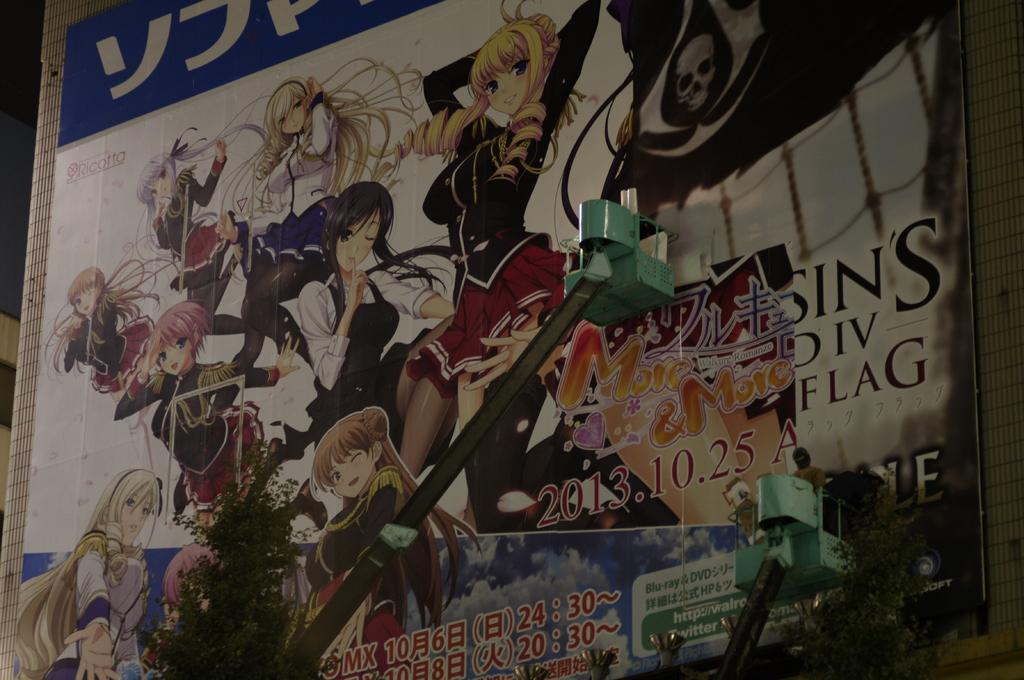What can be seen hanging on the wall in the image? There is a poster in the image. Who or what can be seen in the image besides the poster? People are visible in the image. What type of vegetation is present in the image? Plants are present in the image. What can be read or deciphered in the image? There is text in the image. What else can be seen in the image besides the poster, people, plants, and text? There are objects in the image. What type of cherry is being used to cast a spell in the image? There is no cherry or spell casting present in the image. What type of cover is being used to protect the poster in the image? There is no cover visible in the image; the poster is hanging on the wall without any protection. 